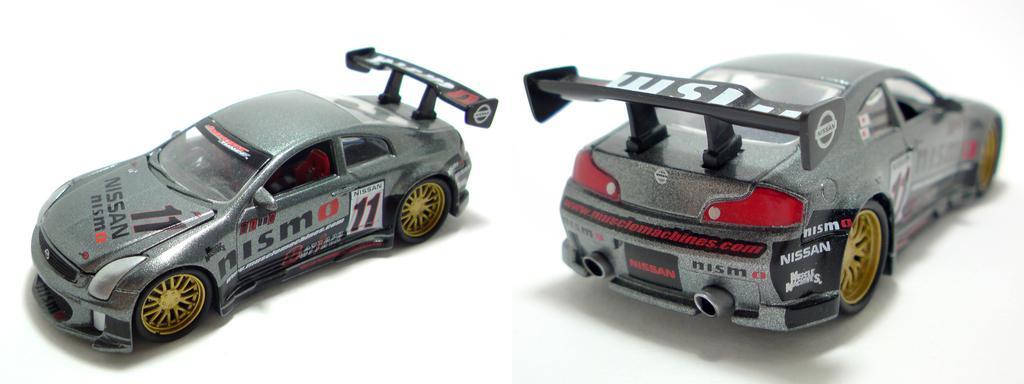In one or two sentences, can you explain what this image depicts? In this image I can see two cars which are grey, black, red and white in color and I can see the wheels of them are black and yellow in color. I can see they are on the white colored surface. 